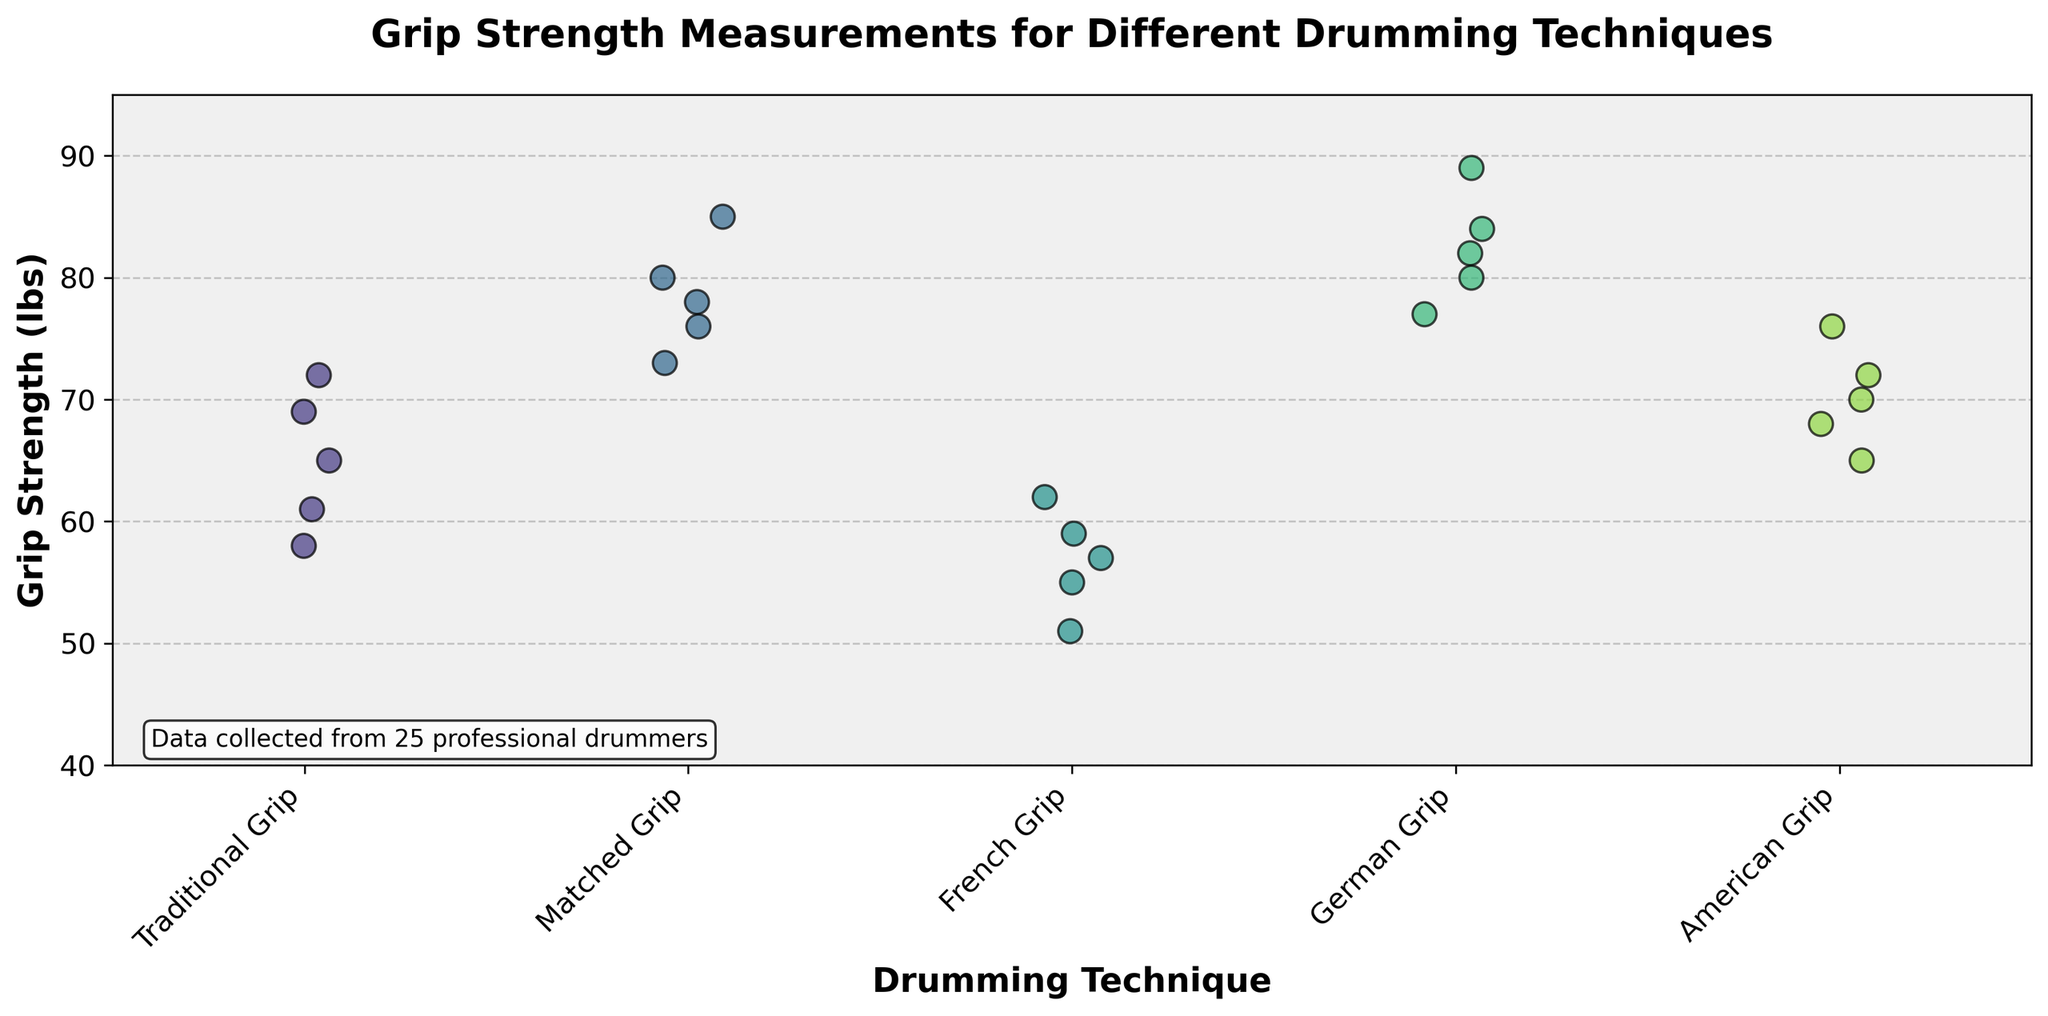What's the title of the figure? The title is written at the top of the figure and is in a larger, bold font. It provides an overview of what the plot represents.
Answer: "Grip Strength Measurements for Different Drumming Techniques" Which grip technique has the highest grip strength measurement? Identify the highest data point on the y-axis and see which technique it aligns with. The highest value is 89 lbs, which falls under the German Grip technique.
Answer: German Grip How many grip strength measurements are there for the Traditional Grip technique? Count the number of data points (dots) along the x-axis for the Traditional Grip category. There are 5 data points.
Answer: 5 What's the average grip strength for the French Grip technique? Add all the grip strength measurements for French Grip (55 + 62 + 51 + 59 + 57) and divide by the number of data points (5). The sum is 284 and the average is 284/5.
Answer: 56.8 Which drumming technique shows the most variability in grip strength measurements? Observe the spread of data points. The Matched Grip technique has a wider spread of data points (73 to 85 lbs), indicating higher variability.
Answer: Matched Grip Compare the highest grip strength in Traditional Grip and Matched Grip. Which is higher? Identify the highest values for both techniques. Traditional Grip's highest is 72 lbs, and Matched Grip's highest is 85 lbs. Matched Grip is higher.
Answer: Matched Grip What is the range of grip strength measurements for the American Grip technique? Find the minimum and maximum values (65 to 76 lbs) and calculate the range by subtracting the minimum from the maximum. The range is 76 - 65.
Answer: 11 lbs Which grip technique has the most densely packed data points? Identify the technique where the data points are closest together. French Grip has closely packed measurements ranging from 51 to 62 lbs.
Answer: French Grip What is the lowest grip strength measurement across all techniques? Find the lowest value on the y-axis. The lowest measurement is 51 lbs, which is for French Grip.
Answer: 51 lbs 